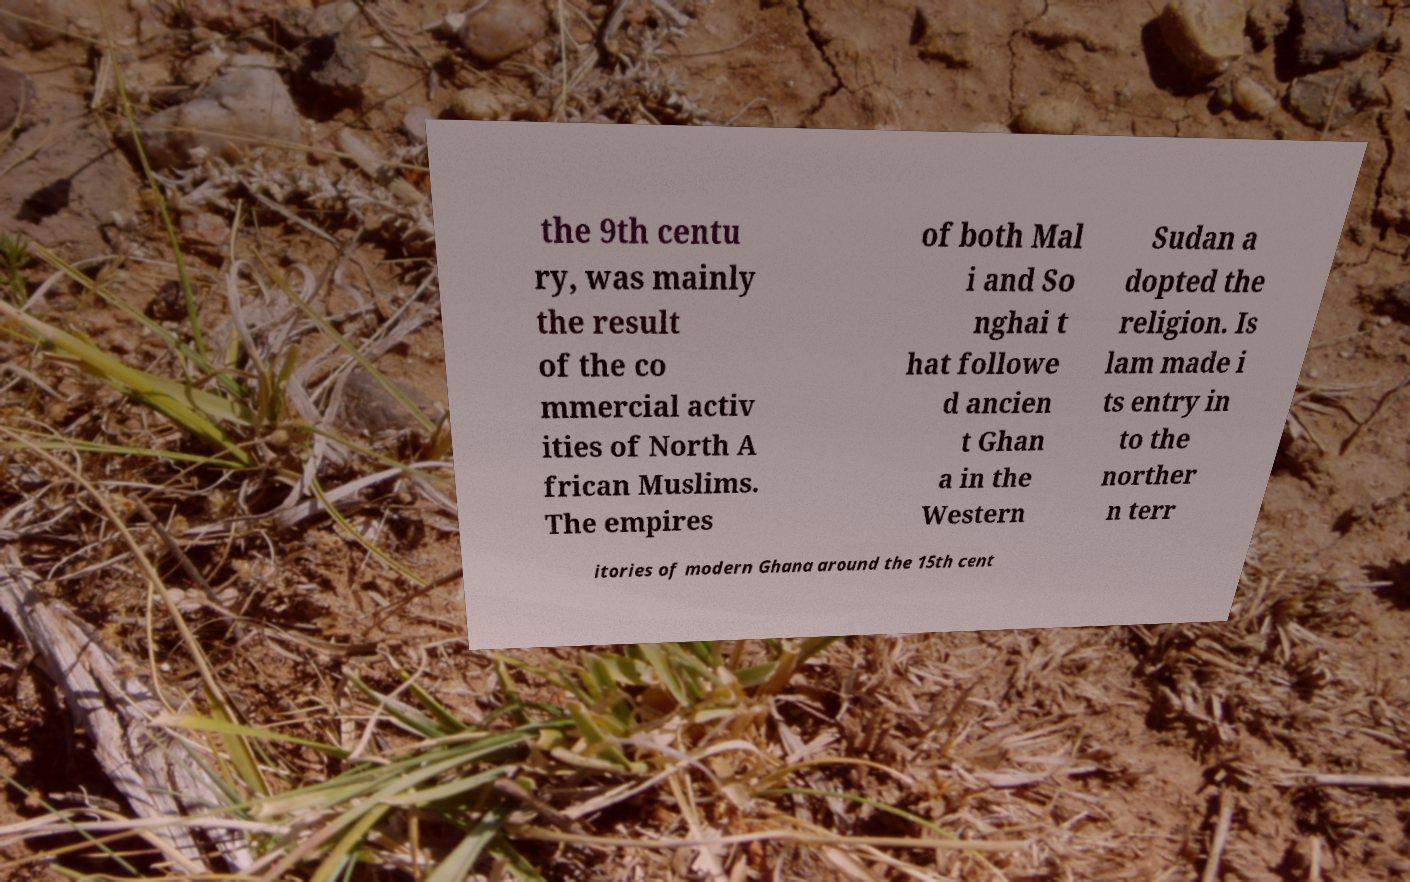For documentation purposes, I need the text within this image transcribed. Could you provide that? the 9th centu ry, was mainly the result of the co mmercial activ ities of North A frican Muslims. The empires of both Mal i and So nghai t hat followe d ancien t Ghan a in the Western Sudan a dopted the religion. Is lam made i ts entry in to the norther n terr itories of modern Ghana around the 15th cent 